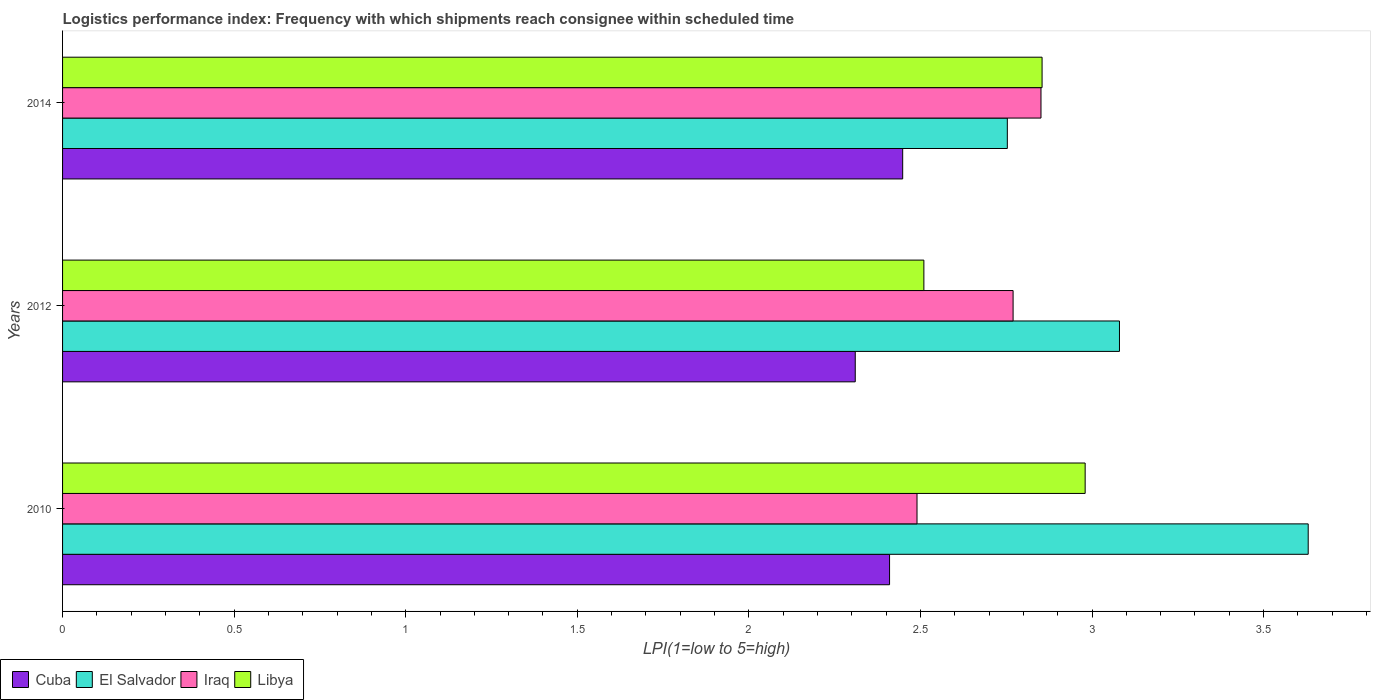Are the number of bars on each tick of the Y-axis equal?
Your response must be concise. Yes. How many bars are there on the 1st tick from the bottom?
Your response must be concise. 4. What is the logistics performance index in Iraq in 2010?
Keep it short and to the point. 2.49. Across all years, what is the maximum logistics performance index in Iraq?
Provide a short and direct response. 2.85. Across all years, what is the minimum logistics performance index in Cuba?
Provide a short and direct response. 2.31. In which year was the logistics performance index in Cuba maximum?
Give a very brief answer. 2014. What is the total logistics performance index in Iraq in the graph?
Offer a very short reply. 8.11. What is the difference between the logistics performance index in Iraq in 2012 and that in 2014?
Your answer should be very brief. -0.08. What is the difference between the logistics performance index in El Salvador in 2010 and the logistics performance index in Iraq in 2012?
Your response must be concise. 0.86. What is the average logistics performance index in Iraq per year?
Offer a terse response. 2.7. In the year 2010, what is the difference between the logistics performance index in Cuba and logistics performance index in El Salvador?
Provide a short and direct response. -1.22. What is the ratio of the logistics performance index in Libya in 2012 to that in 2014?
Make the answer very short. 0.88. Is the difference between the logistics performance index in Cuba in 2010 and 2014 greater than the difference between the logistics performance index in El Salvador in 2010 and 2014?
Make the answer very short. No. What is the difference between the highest and the second highest logistics performance index in Iraq?
Provide a succinct answer. 0.08. What is the difference between the highest and the lowest logistics performance index in Libya?
Keep it short and to the point. 0.47. Is the sum of the logistics performance index in Libya in 2012 and 2014 greater than the maximum logistics performance index in Cuba across all years?
Give a very brief answer. Yes. What does the 4th bar from the top in 2012 represents?
Provide a succinct answer. Cuba. What does the 2nd bar from the bottom in 2012 represents?
Keep it short and to the point. El Salvador. How many bars are there?
Your response must be concise. 12. What is the difference between two consecutive major ticks on the X-axis?
Offer a very short reply. 0.5. Are the values on the major ticks of X-axis written in scientific E-notation?
Your response must be concise. No. Where does the legend appear in the graph?
Keep it short and to the point. Bottom left. How many legend labels are there?
Your answer should be compact. 4. How are the legend labels stacked?
Offer a very short reply. Horizontal. What is the title of the graph?
Your answer should be compact. Logistics performance index: Frequency with which shipments reach consignee within scheduled time. What is the label or title of the X-axis?
Ensure brevity in your answer.  LPI(1=low to 5=high). What is the label or title of the Y-axis?
Offer a very short reply. Years. What is the LPI(1=low to 5=high) in Cuba in 2010?
Provide a succinct answer. 2.41. What is the LPI(1=low to 5=high) of El Salvador in 2010?
Keep it short and to the point. 3.63. What is the LPI(1=low to 5=high) in Iraq in 2010?
Keep it short and to the point. 2.49. What is the LPI(1=low to 5=high) of Libya in 2010?
Your response must be concise. 2.98. What is the LPI(1=low to 5=high) of Cuba in 2012?
Offer a very short reply. 2.31. What is the LPI(1=low to 5=high) of El Salvador in 2012?
Make the answer very short. 3.08. What is the LPI(1=low to 5=high) in Iraq in 2012?
Ensure brevity in your answer.  2.77. What is the LPI(1=low to 5=high) in Libya in 2012?
Provide a short and direct response. 2.51. What is the LPI(1=low to 5=high) in Cuba in 2014?
Provide a short and direct response. 2.45. What is the LPI(1=low to 5=high) in El Salvador in 2014?
Your response must be concise. 2.75. What is the LPI(1=low to 5=high) of Iraq in 2014?
Ensure brevity in your answer.  2.85. What is the LPI(1=low to 5=high) of Libya in 2014?
Keep it short and to the point. 2.85. Across all years, what is the maximum LPI(1=low to 5=high) of Cuba?
Give a very brief answer. 2.45. Across all years, what is the maximum LPI(1=low to 5=high) of El Salvador?
Your response must be concise. 3.63. Across all years, what is the maximum LPI(1=low to 5=high) of Iraq?
Give a very brief answer. 2.85. Across all years, what is the maximum LPI(1=low to 5=high) in Libya?
Provide a succinct answer. 2.98. Across all years, what is the minimum LPI(1=low to 5=high) of Cuba?
Keep it short and to the point. 2.31. Across all years, what is the minimum LPI(1=low to 5=high) of El Salvador?
Offer a terse response. 2.75. Across all years, what is the minimum LPI(1=low to 5=high) of Iraq?
Your response must be concise. 2.49. Across all years, what is the minimum LPI(1=low to 5=high) in Libya?
Give a very brief answer. 2.51. What is the total LPI(1=low to 5=high) of Cuba in the graph?
Give a very brief answer. 7.17. What is the total LPI(1=low to 5=high) in El Salvador in the graph?
Ensure brevity in your answer.  9.46. What is the total LPI(1=low to 5=high) in Iraq in the graph?
Keep it short and to the point. 8.11. What is the total LPI(1=low to 5=high) in Libya in the graph?
Give a very brief answer. 8.34. What is the difference between the LPI(1=low to 5=high) of El Salvador in 2010 and that in 2012?
Provide a succinct answer. 0.55. What is the difference between the LPI(1=low to 5=high) in Iraq in 2010 and that in 2012?
Provide a succinct answer. -0.28. What is the difference between the LPI(1=low to 5=high) of Libya in 2010 and that in 2012?
Your answer should be very brief. 0.47. What is the difference between the LPI(1=low to 5=high) of Cuba in 2010 and that in 2014?
Provide a short and direct response. -0.04. What is the difference between the LPI(1=low to 5=high) in El Salvador in 2010 and that in 2014?
Offer a terse response. 0.88. What is the difference between the LPI(1=low to 5=high) in Iraq in 2010 and that in 2014?
Your answer should be compact. -0.36. What is the difference between the LPI(1=low to 5=high) of Libya in 2010 and that in 2014?
Provide a short and direct response. 0.13. What is the difference between the LPI(1=low to 5=high) of Cuba in 2012 and that in 2014?
Give a very brief answer. -0.14. What is the difference between the LPI(1=low to 5=high) of El Salvador in 2012 and that in 2014?
Ensure brevity in your answer.  0.33. What is the difference between the LPI(1=low to 5=high) in Iraq in 2012 and that in 2014?
Offer a very short reply. -0.08. What is the difference between the LPI(1=low to 5=high) of Libya in 2012 and that in 2014?
Provide a short and direct response. -0.34. What is the difference between the LPI(1=low to 5=high) in Cuba in 2010 and the LPI(1=low to 5=high) in El Salvador in 2012?
Make the answer very short. -0.67. What is the difference between the LPI(1=low to 5=high) in Cuba in 2010 and the LPI(1=low to 5=high) in Iraq in 2012?
Your answer should be compact. -0.36. What is the difference between the LPI(1=low to 5=high) of Cuba in 2010 and the LPI(1=low to 5=high) of Libya in 2012?
Provide a succinct answer. -0.1. What is the difference between the LPI(1=low to 5=high) of El Salvador in 2010 and the LPI(1=low to 5=high) of Iraq in 2012?
Make the answer very short. 0.86. What is the difference between the LPI(1=low to 5=high) of El Salvador in 2010 and the LPI(1=low to 5=high) of Libya in 2012?
Provide a succinct answer. 1.12. What is the difference between the LPI(1=low to 5=high) of Iraq in 2010 and the LPI(1=low to 5=high) of Libya in 2012?
Ensure brevity in your answer.  -0.02. What is the difference between the LPI(1=low to 5=high) of Cuba in 2010 and the LPI(1=low to 5=high) of El Salvador in 2014?
Provide a succinct answer. -0.34. What is the difference between the LPI(1=low to 5=high) of Cuba in 2010 and the LPI(1=low to 5=high) of Iraq in 2014?
Your response must be concise. -0.44. What is the difference between the LPI(1=low to 5=high) of Cuba in 2010 and the LPI(1=low to 5=high) of Libya in 2014?
Offer a very short reply. -0.44. What is the difference between the LPI(1=low to 5=high) in El Salvador in 2010 and the LPI(1=low to 5=high) in Iraq in 2014?
Your answer should be very brief. 0.78. What is the difference between the LPI(1=low to 5=high) in El Salvador in 2010 and the LPI(1=low to 5=high) in Libya in 2014?
Offer a terse response. 0.78. What is the difference between the LPI(1=low to 5=high) of Iraq in 2010 and the LPI(1=low to 5=high) of Libya in 2014?
Make the answer very short. -0.36. What is the difference between the LPI(1=low to 5=high) in Cuba in 2012 and the LPI(1=low to 5=high) in El Salvador in 2014?
Give a very brief answer. -0.44. What is the difference between the LPI(1=low to 5=high) in Cuba in 2012 and the LPI(1=low to 5=high) in Iraq in 2014?
Give a very brief answer. -0.54. What is the difference between the LPI(1=low to 5=high) of Cuba in 2012 and the LPI(1=low to 5=high) of Libya in 2014?
Your answer should be very brief. -0.54. What is the difference between the LPI(1=low to 5=high) in El Salvador in 2012 and the LPI(1=low to 5=high) in Iraq in 2014?
Provide a succinct answer. 0.23. What is the difference between the LPI(1=low to 5=high) in El Salvador in 2012 and the LPI(1=low to 5=high) in Libya in 2014?
Keep it short and to the point. 0.23. What is the difference between the LPI(1=low to 5=high) in Iraq in 2012 and the LPI(1=low to 5=high) in Libya in 2014?
Give a very brief answer. -0.08. What is the average LPI(1=low to 5=high) in Cuba per year?
Your answer should be compact. 2.39. What is the average LPI(1=low to 5=high) in El Salvador per year?
Make the answer very short. 3.15. What is the average LPI(1=low to 5=high) in Iraq per year?
Your answer should be very brief. 2.7. What is the average LPI(1=low to 5=high) in Libya per year?
Provide a short and direct response. 2.78. In the year 2010, what is the difference between the LPI(1=low to 5=high) in Cuba and LPI(1=low to 5=high) in El Salvador?
Make the answer very short. -1.22. In the year 2010, what is the difference between the LPI(1=low to 5=high) in Cuba and LPI(1=low to 5=high) in Iraq?
Offer a terse response. -0.08. In the year 2010, what is the difference between the LPI(1=low to 5=high) in Cuba and LPI(1=low to 5=high) in Libya?
Offer a very short reply. -0.57. In the year 2010, what is the difference between the LPI(1=low to 5=high) of El Salvador and LPI(1=low to 5=high) of Iraq?
Ensure brevity in your answer.  1.14. In the year 2010, what is the difference between the LPI(1=low to 5=high) in El Salvador and LPI(1=low to 5=high) in Libya?
Ensure brevity in your answer.  0.65. In the year 2010, what is the difference between the LPI(1=low to 5=high) of Iraq and LPI(1=low to 5=high) of Libya?
Provide a succinct answer. -0.49. In the year 2012, what is the difference between the LPI(1=low to 5=high) in Cuba and LPI(1=low to 5=high) in El Salvador?
Keep it short and to the point. -0.77. In the year 2012, what is the difference between the LPI(1=low to 5=high) of Cuba and LPI(1=low to 5=high) of Iraq?
Your answer should be compact. -0.46. In the year 2012, what is the difference between the LPI(1=low to 5=high) in El Salvador and LPI(1=low to 5=high) in Iraq?
Your answer should be compact. 0.31. In the year 2012, what is the difference between the LPI(1=low to 5=high) of El Salvador and LPI(1=low to 5=high) of Libya?
Offer a terse response. 0.57. In the year 2012, what is the difference between the LPI(1=low to 5=high) of Iraq and LPI(1=low to 5=high) of Libya?
Your response must be concise. 0.26. In the year 2014, what is the difference between the LPI(1=low to 5=high) in Cuba and LPI(1=low to 5=high) in El Salvador?
Keep it short and to the point. -0.3. In the year 2014, what is the difference between the LPI(1=low to 5=high) in Cuba and LPI(1=low to 5=high) in Iraq?
Give a very brief answer. -0.4. In the year 2014, what is the difference between the LPI(1=low to 5=high) of Cuba and LPI(1=low to 5=high) of Libya?
Provide a succinct answer. -0.41. In the year 2014, what is the difference between the LPI(1=low to 5=high) of El Salvador and LPI(1=low to 5=high) of Iraq?
Offer a terse response. -0.1. In the year 2014, what is the difference between the LPI(1=low to 5=high) of El Salvador and LPI(1=low to 5=high) of Libya?
Your answer should be compact. -0.1. In the year 2014, what is the difference between the LPI(1=low to 5=high) of Iraq and LPI(1=low to 5=high) of Libya?
Your answer should be very brief. -0. What is the ratio of the LPI(1=low to 5=high) of Cuba in 2010 to that in 2012?
Provide a succinct answer. 1.04. What is the ratio of the LPI(1=low to 5=high) of El Salvador in 2010 to that in 2012?
Your answer should be compact. 1.18. What is the ratio of the LPI(1=low to 5=high) of Iraq in 2010 to that in 2012?
Make the answer very short. 0.9. What is the ratio of the LPI(1=low to 5=high) in Libya in 2010 to that in 2012?
Provide a short and direct response. 1.19. What is the ratio of the LPI(1=low to 5=high) of Cuba in 2010 to that in 2014?
Keep it short and to the point. 0.98. What is the ratio of the LPI(1=low to 5=high) of El Salvador in 2010 to that in 2014?
Give a very brief answer. 1.32. What is the ratio of the LPI(1=low to 5=high) of Iraq in 2010 to that in 2014?
Your response must be concise. 0.87. What is the ratio of the LPI(1=low to 5=high) of Libya in 2010 to that in 2014?
Ensure brevity in your answer.  1.04. What is the ratio of the LPI(1=low to 5=high) of Cuba in 2012 to that in 2014?
Provide a short and direct response. 0.94. What is the ratio of the LPI(1=low to 5=high) of El Salvador in 2012 to that in 2014?
Your answer should be very brief. 1.12. What is the ratio of the LPI(1=low to 5=high) of Iraq in 2012 to that in 2014?
Keep it short and to the point. 0.97. What is the ratio of the LPI(1=low to 5=high) in Libya in 2012 to that in 2014?
Provide a short and direct response. 0.88. What is the difference between the highest and the second highest LPI(1=low to 5=high) of Cuba?
Provide a short and direct response. 0.04. What is the difference between the highest and the second highest LPI(1=low to 5=high) of El Salvador?
Provide a succinct answer. 0.55. What is the difference between the highest and the second highest LPI(1=low to 5=high) in Iraq?
Keep it short and to the point. 0.08. What is the difference between the highest and the second highest LPI(1=low to 5=high) of Libya?
Provide a short and direct response. 0.13. What is the difference between the highest and the lowest LPI(1=low to 5=high) in Cuba?
Give a very brief answer. 0.14. What is the difference between the highest and the lowest LPI(1=low to 5=high) in El Salvador?
Ensure brevity in your answer.  0.88. What is the difference between the highest and the lowest LPI(1=low to 5=high) in Iraq?
Give a very brief answer. 0.36. What is the difference between the highest and the lowest LPI(1=low to 5=high) of Libya?
Ensure brevity in your answer.  0.47. 